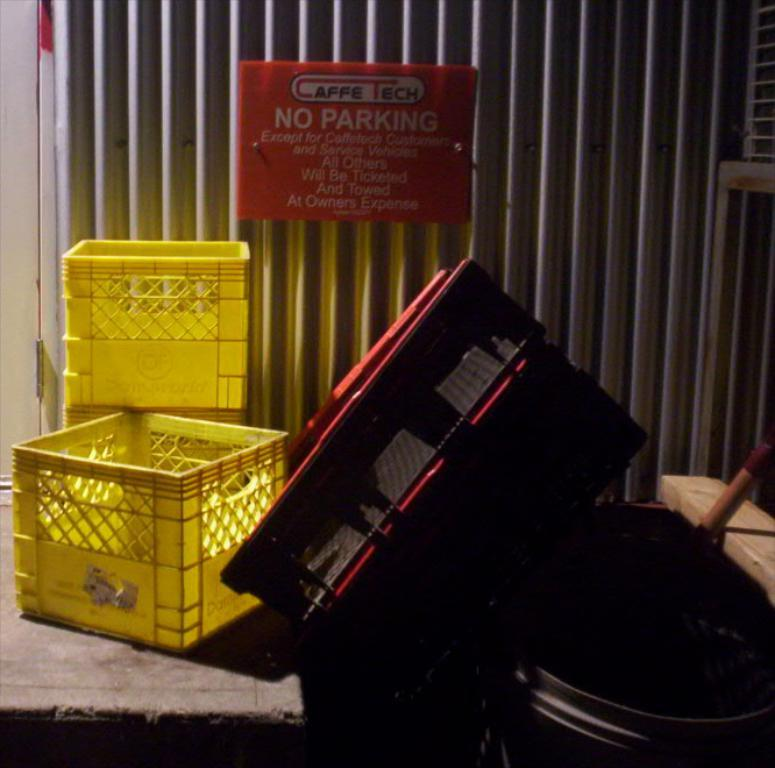How many yellow trays are in the image? There are two yellow trays in the image. What else can be seen in the image besides the yellow trays? There are other things visible in the image, including a red board. What color is the board in the image? The board in the image is red. Is there any text or information on the red board? Yes, something is written on the red board. Are there any wires hanging from the yellow trays in the image? There is no mention of wires in the image, so we cannot determine if any are present. 